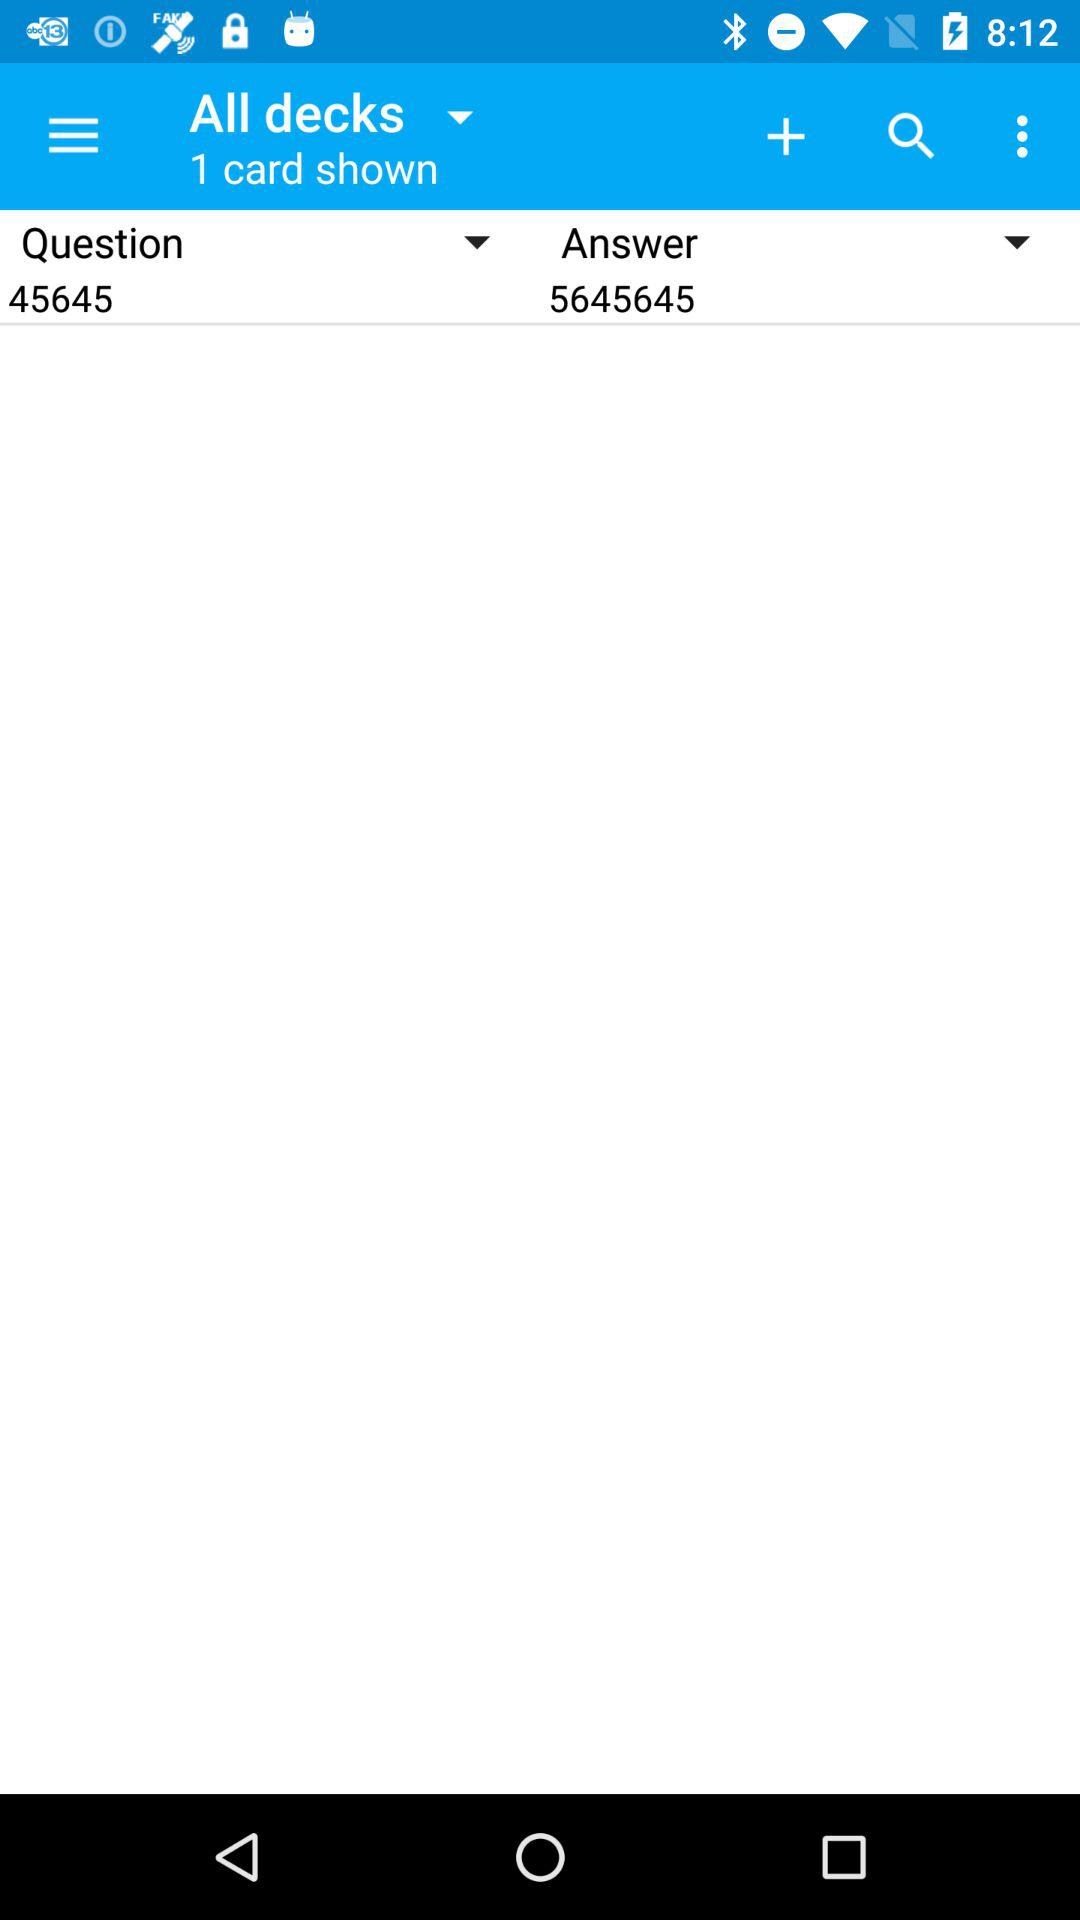What is the answer number? The answer number is 5645645. 